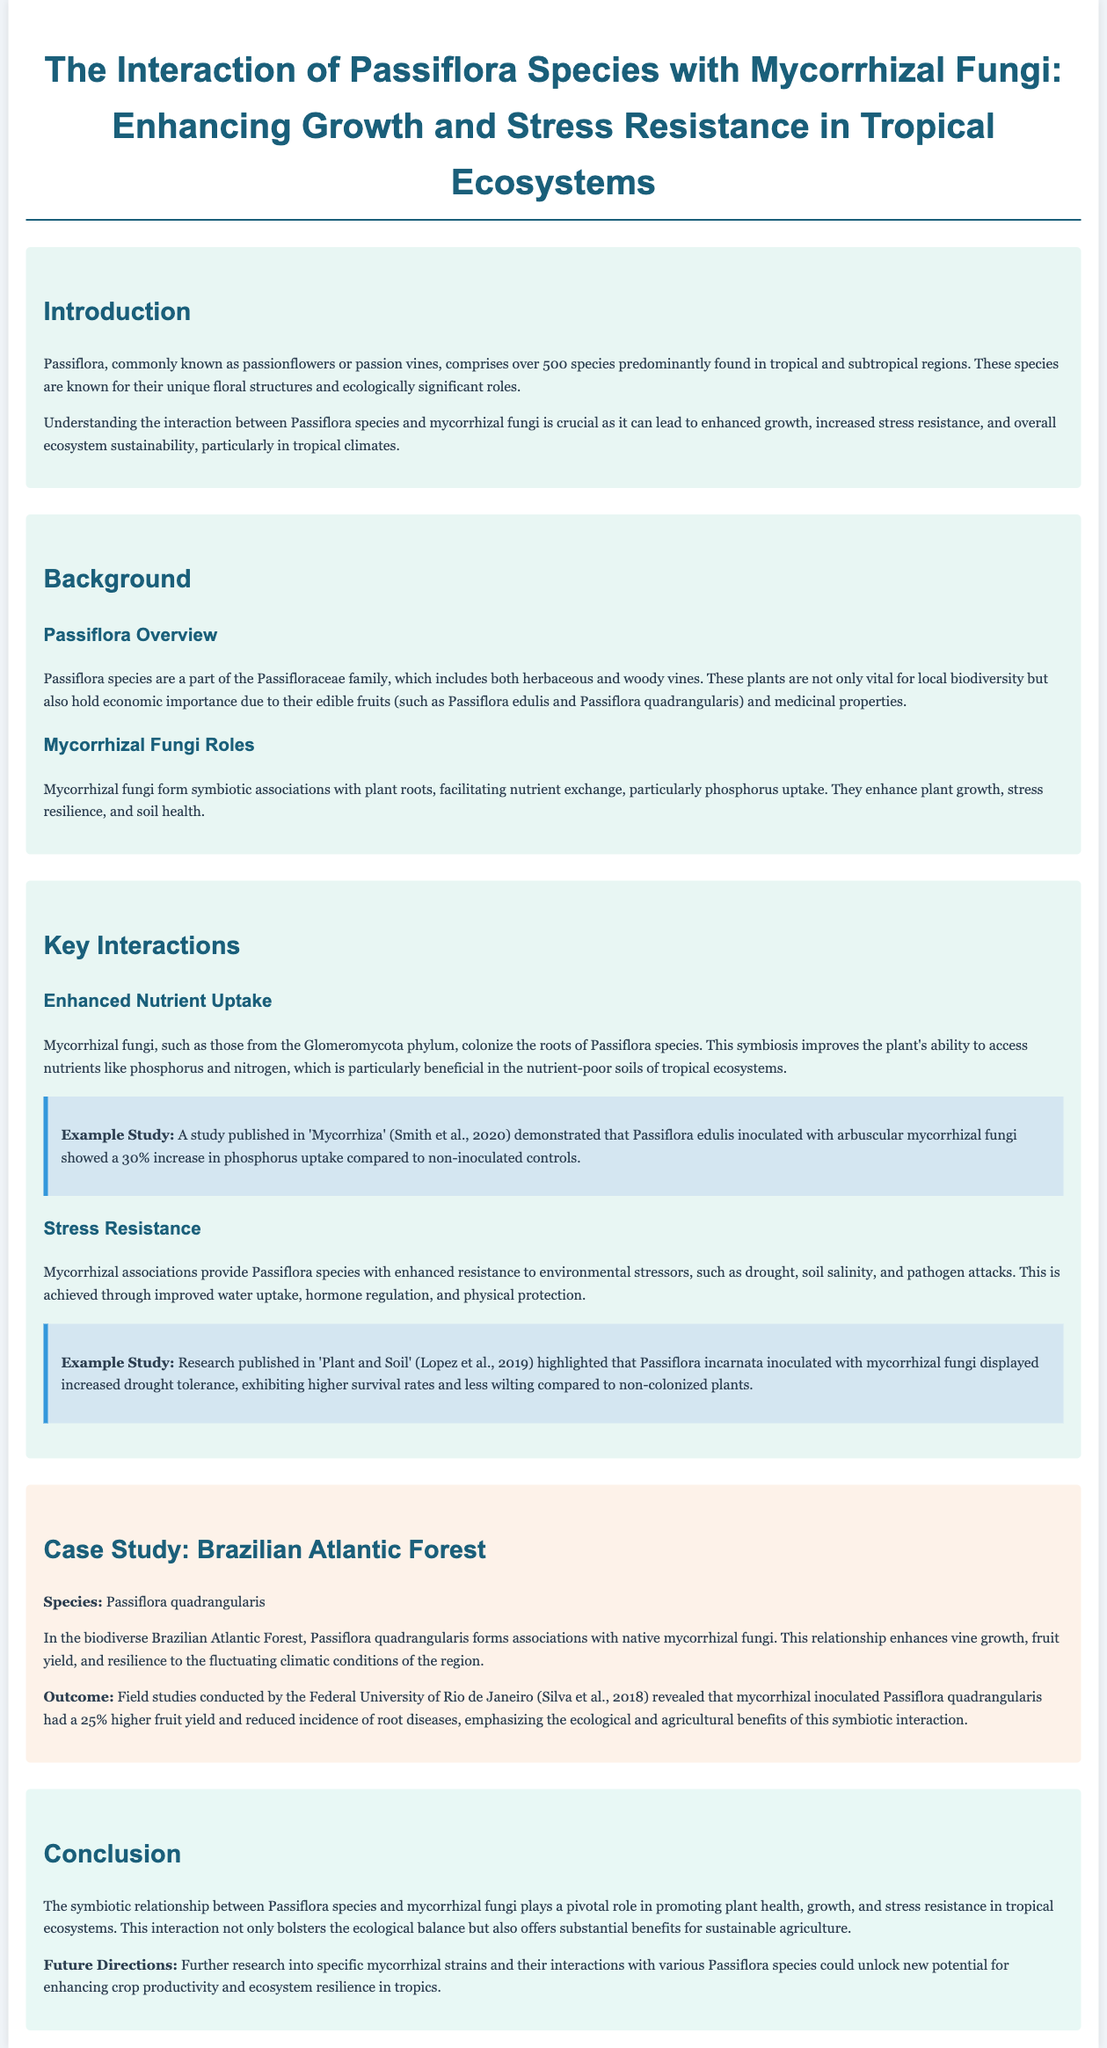What is the title of the whitepaper? The title of the whitepaper is explicitly mentioned at the beginning.
Answer: The Interaction of Passiflora Species with Mycorrhizal Fungi: Enhancing Growth and Stress Resistance in Tropical Ecosystems How many species are primarily found in the Passiflora genus? The document states that there are over 500 species in the Passiflora genus.
Answer: Over 500 species Which family does Passiflora belong to? The family to which Passiflora belongs is specified in the background section.
Answer: Passifloraceae What is one of the key benefits of mycorrhizal fungi mentioned in the document? The document outlines the beneficial roles of mycorrhizal fungi in relation to plant health, specifically nutrient uptake.
Answer: Enhanced nutrient uptake What specific type of mycorrhizal fungi is mentioned in the document? The document identifies a specific group of fungi from a particular phylum.
Answer: Glomeromycota What percentage increase in phosphorus uptake was observed in Passiflora edulis inoculated with mycorrhizal fungi? A specific percentage increase in nutrient uptake of Passiflora edulis is noted in an example study.
Answer: 30% In which ecosystem was the case study on Passiflora quadrangularis conducted? The document mentions a specific biodiverse region where the case study was carried out.
Answer: Brazilian Atlantic Forest What was the higher fruit yield percentage observed in mycorrhizal inoculated Passiflora quadrangularis? The document states the specific percentage increase in fruit yield due to mycorrhizal inoculation.
Answer: 25% What is suggested as a future direction for research within the document? The conclusion section highlights potential research avenues that could be explored.
Answer: Specific mycorrhizal strains 